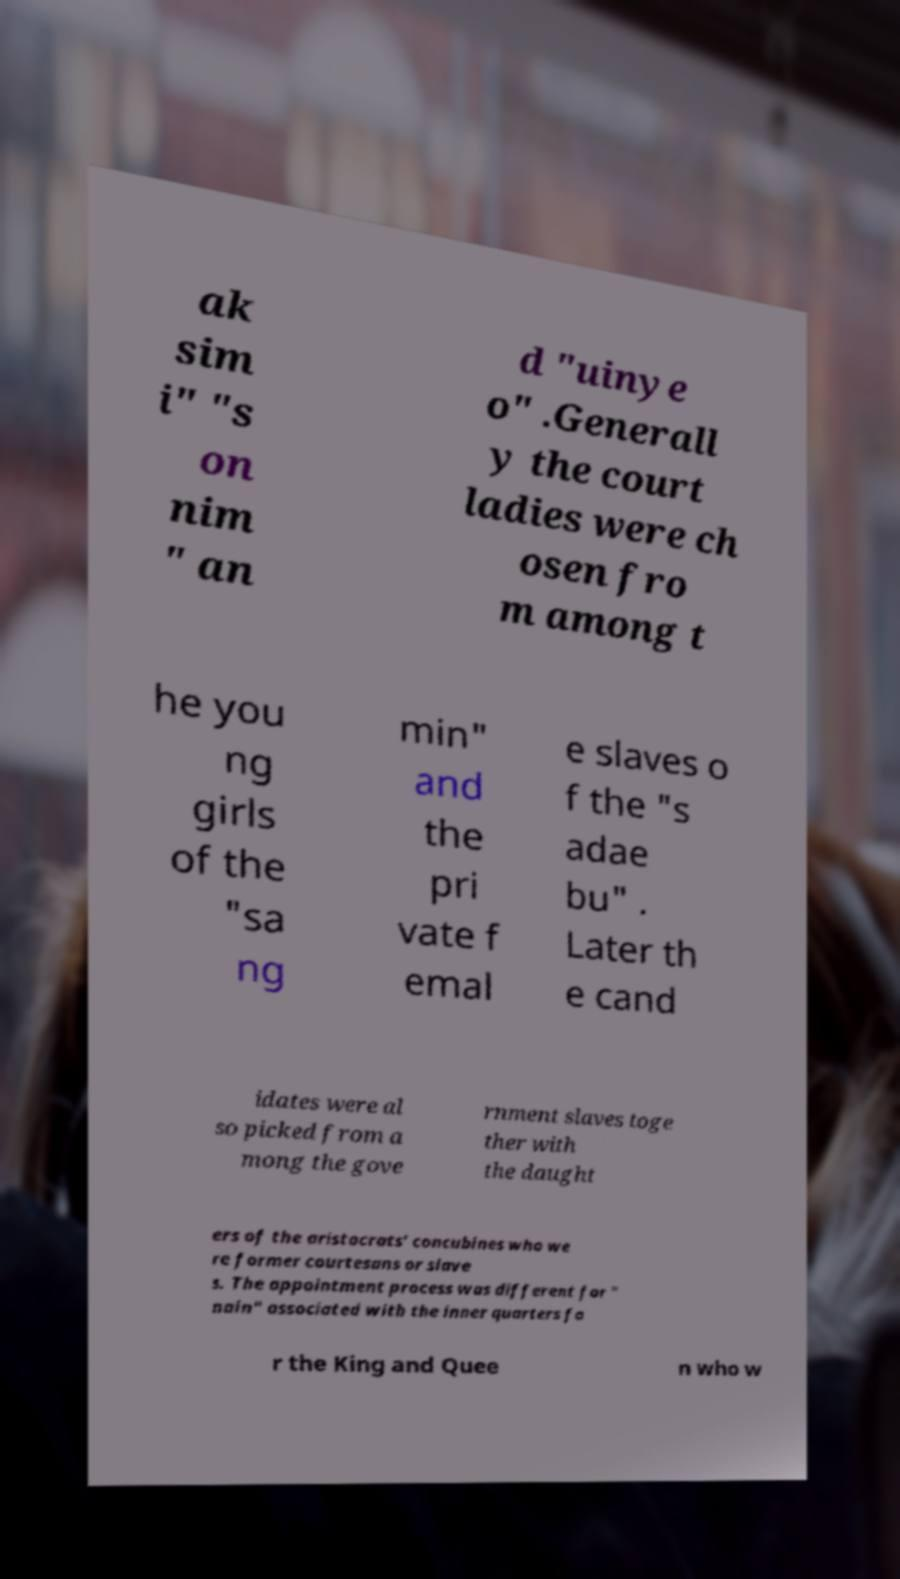Can you read and provide the text displayed in the image?This photo seems to have some interesting text. Can you extract and type it out for me? ak sim i" "s on nim " an d "uinye o" .Generall y the court ladies were ch osen fro m among t he you ng girls of the "sa ng min" and the pri vate f emal e slaves o f the "s adae bu" . Later th e cand idates were al so picked from a mong the gove rnment slaves toge ther with the daught ers of the aristocrats’ concubines who we re former courtesans or slave s. The appointment process was different for " nain" associated with the inner quarters fo r the King and Quee n who w 